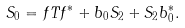Convert formula to latex. <formula><loc_0><loc_0><loc_500><loc_500>S _ { 0 } = f T f ^ { * } + b _ { 0 } S _ { 2 } + S _ { 2 } b ^ { * } _ { 0 } .</formula> 